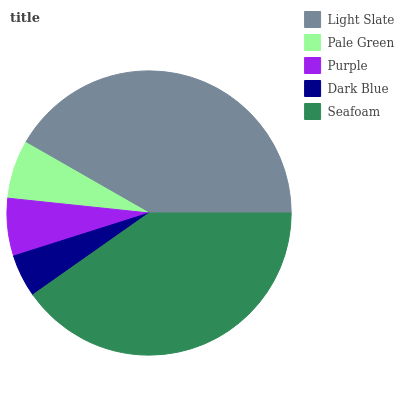Is Dark Blue the minimum?
Answer yes or no. Yes. Is Light Slate the maximum?
Answer yes or no. Yes. Is Pale Green the minimum?
Answer yes or no. No. Is Pale Green the maximum?
Answer yes or no. No. Is Light Slate greater than Pale Green?
Answer yes or no. Yes. Is Pale Green less than Light Slate?
Answer yes or no. Yes. Is Pale Green greater than Light Slate?
Answer yes or no. No. Is Light Slate less than Pale Green?
Answer yes or no. No. Is Pale Green the high median?
Answer yes or no. Yes. Is Pale Green the low median?
Answer yes or no. Yes. Is Seafoam the high median?
Answer yes or no. No. Is Light Slate the low median?
Answer yes or no. No. 